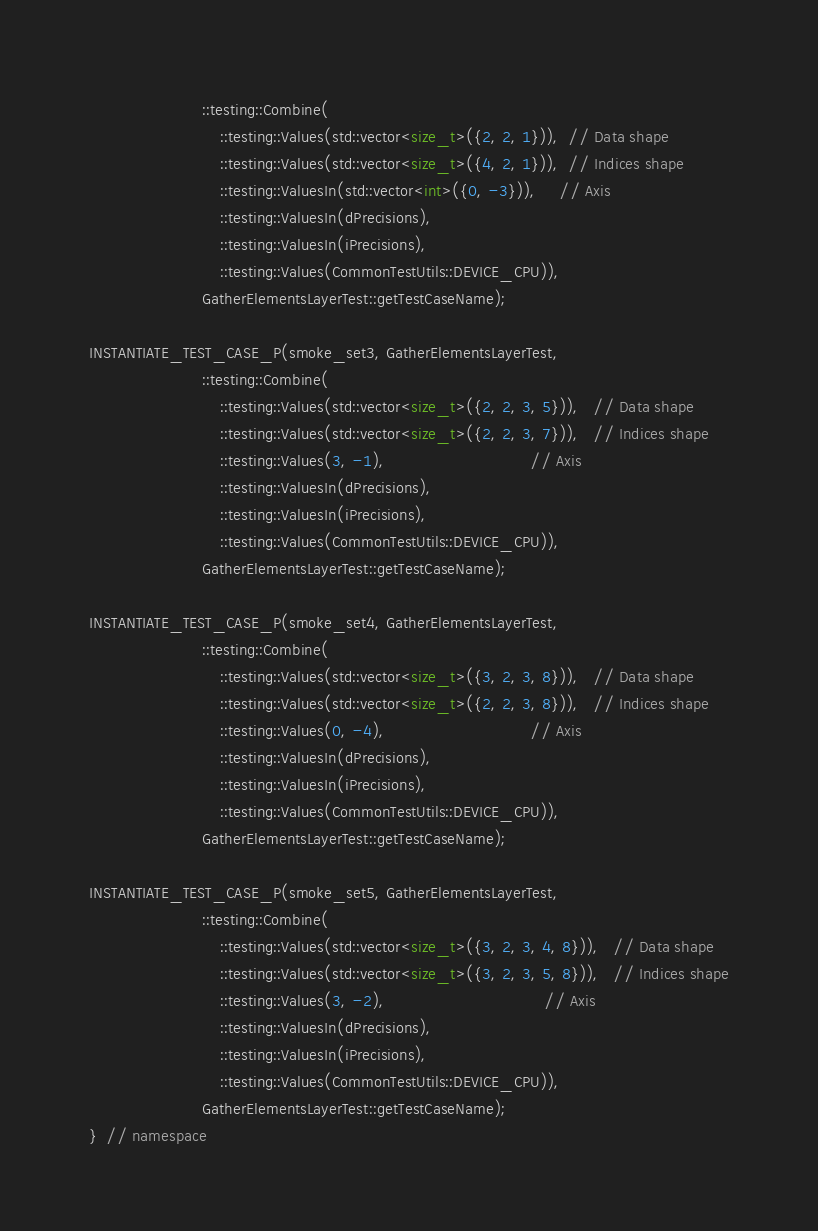<code> <loc_0><loc_0><loc_500><loc_500><_C++_>                        ::testing::Combine(
                            ::testing::Values(std::vector<size_t>({2, 2, 1})),  // Data shape
                            ::testing::Values(std::vector<size_t>({4, 2, 1})),  // Indices shape
                            ::testing::ValuesIn(std::vector<int>({0, -3})),     // Axis
                            ::testing::ValuesIn(dPrecisions),
                            ::testing::ValuesIn(iPrecisions),
                            ::testing::Values(CommonTestUtils::DEVICE_CPU)),
                        GatherElementsLayerTest::getTestCaseName);

INSTANTIATE_TEST_CASE_P(smoke_set3, GatherElementsLayerTest,
                        ::testing::Combine(
                            ::testing::Values(std::vector<size_t>({2, 2, 3, 5})),   // Data shape
                            ::testing::Values(std::vector<size_t>({2, 2, 3, 7})),   // Indices shape
                            ::testing::Values(3, -1),                               // Axis
                            ::testing::ValuesIn(dPrecisions),
                            ::testing::ValuesIn(iPrecisions),
                            ::testing::Values(CommonTestUtils::DEVICE_CPU)),
                        GatherElementsLayerTest::getTestCaseName);

INSTANTIATE_TEST_CASE_P(smoke_set4, GatherElementsLayerTest,
                        ::testing::Combine(
                            ::testing::Values(std::vector<size_t>({3, 2, 3, 8})),   // Data shape
                            ::testing::Values(std::vector<size_t>({2, 2, 3, 8})),   // Indices shape
                            ::testing::Values(0, -4),                               // Axis
                            ::testing::ValuesIn(dPrecisions),
                            ::testing::ValuesIn(iPrecisions),
                            ::testing::Values(CommonTestUtils::DEVICE_CPU)),
                        GatherElementsLayerTest::getTestCaseName);

INSTANTIATE_TEST_CASE_P(smoke_set5, GatherElementsLayerTest,
                        ::testing::Combine(
                            ::testing::Values(std::vector<size_t>({3, 2, 3, 4, 8})),   // Data shape
                            ::testing::Values(std::vector<size_t>({3, 2, 3, 5, 8})),   // Indices shape
                            ::testing::Values(3, -2),                                  // Axis
                            ::testing::ValuesIn(dPrecisions),
                            ::testing::ValuesIn(iPrecisions),
                            ::testing::Values(CommonTestUtils::DEVICE_CPU)),
                        GatherElementsLayerTest::getTestCaseName);
}  // namespace</code> 